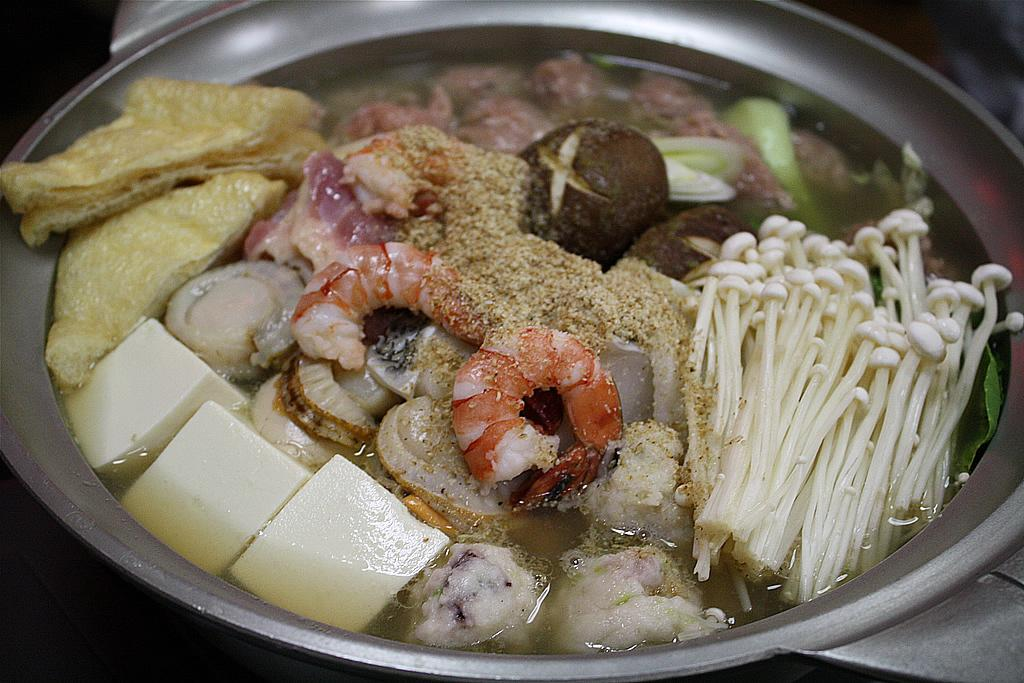What is in the bowl that is visible in the image? There is food in a bowl in the image. Can you describe the background of the image? The background of the image is dark and blurred. What type of rice can be seen in the image? There is no rice present in the image; it only shows food in a bowl. What type of copper object is visible in the image? There is no copper object present in the image. 